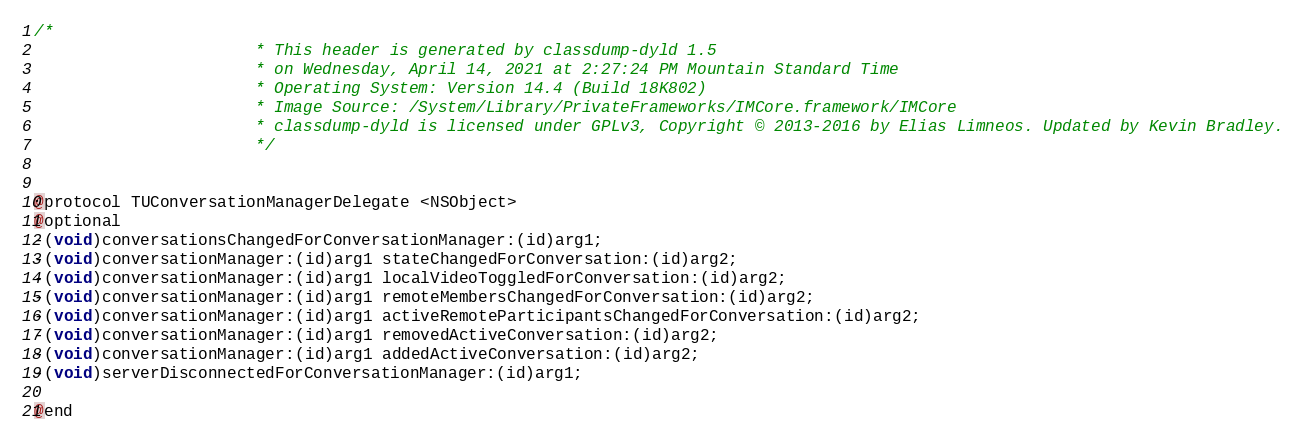Convert code to text. <code><loc_0><loc_0><loc_500><loc_500><_C_>/*
                       * This header is generated by classdump-dyld 1.5
                       * on Wednesday, April 14, 2021 at 2:27:24 PM Mountain Standard Time
                       * Operating System: Version 14.4 (Build 18K802)
                       * Image Source: /System/Library/PrivateFrameworks/IMCore.framework/IMCore
                       * classdump-dyld is licensed under GPLv3, Copyright © 2013-2016 by Elias Limneos. Updated by Kevin Bradley.
                       */


@protocol TUConversationManagerDelegate <NSObject>
@optional
-(void)conversationsChangedForConversationManager:(id)arg1;
-(void)conversationManager:(id)arg1 stateChangedForConversation:(id)arg2;
-(void)conversationManager:(id)arg1 localVideoToggledForConversation:(id)arg2;
-(void)conversationManager:(id)arg1 remoteMembersChangedForConversation:(id)arg2;
-(void)conversationManager:(id)arg1 activeRemoteParticipantsChangedForConversation:(id)arg2;
-(void)conversationManager:(id)arg1 removedActiveConversation:(id)arg2;
-(void)conversationManager:(id)arg1 addedActiveConversation:(id)arg2;
-(void)serverDisconnectedForConversationManager:(id)arg1;

@end

</code> 